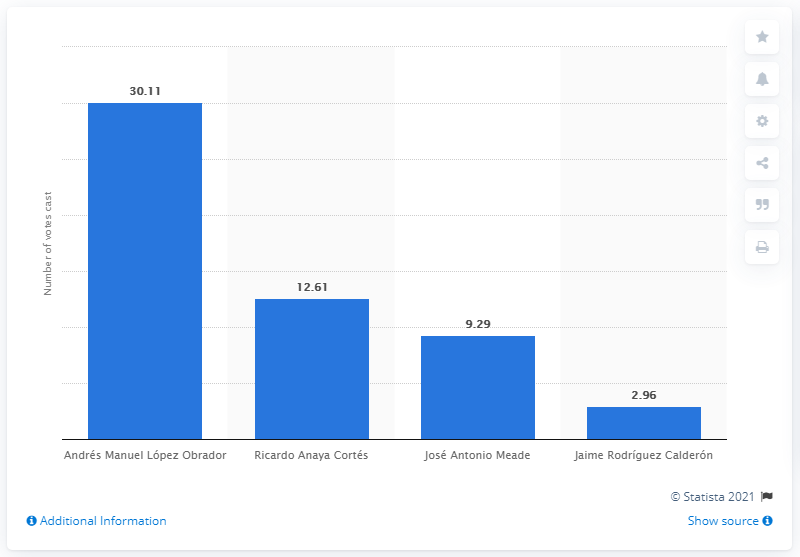How many votes did Andrés Manuel López Obrador get? According to the bar chart, Andrés Manuel López Obrador received 30.11 million votes, which is significantly higher than the other candidates presented in the image. 